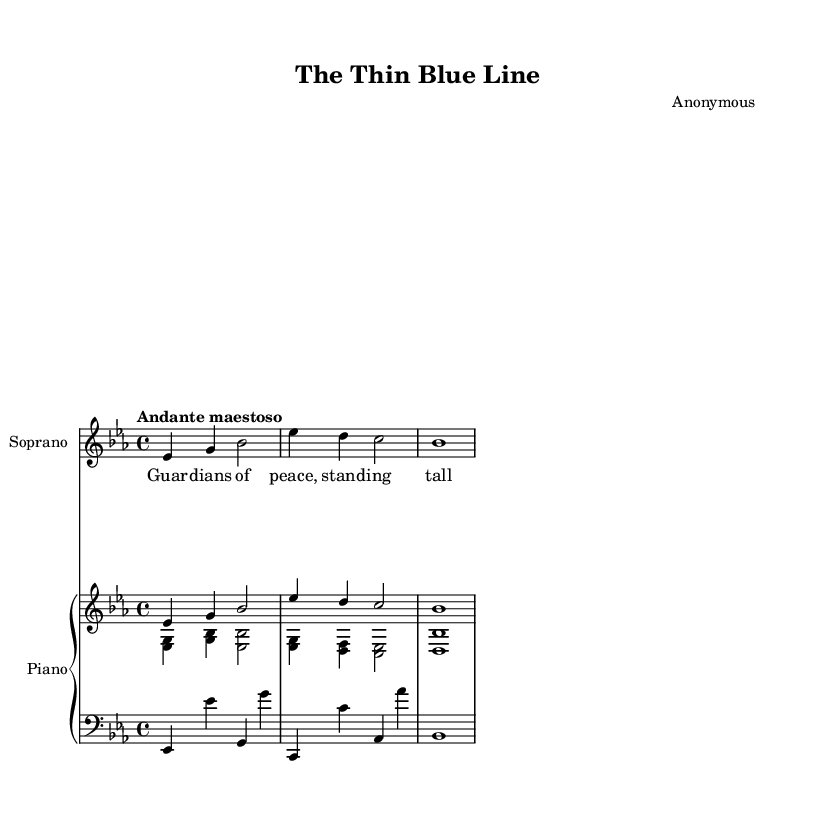What is the key signature of this music? The key signature is determined by the number of sharps or flats at the beginning of the staff. In this sheet music, there are three flats (B, E, and A), which indicates that it is in E-flat major.
Answer: E-flat major What is the time signature of this piece? The time signature is indicated at the beginning of the staff just after the key signature. It shows 4 over 4, meaning four beats per measure and a quarter note gets one beat.
Answer: 4/4 What is the tempo marking given for this piece? The tempo is specified in the sheet music, showing how fast the piece should be played. In this case, the term "Andante maestoso" indicates a moderate tempo that is dignified and majestic in character.
Answer: Andante maestoso Which instrument is specified as the primary performer in the score? The primary instrument is noted at the start of the staff for the vocal line, which is labeled as "Soprano." This indicates that the Soprano voice is the main performer for the melody.
Answer: Soprano What is the harmonic structure presented in the left hand of the piano part? The left hand in the piano part contains a series of chords. It begins with the notes E-flat and G, forming the first chord in E-flat major. The notes progress through various chords corresponding to the music's harmonic progression.
Answer: E-flat major chord How many measures are in the melody line? The melody line is represented in the score with clear bar lines indicating measures. There are three visible measures for the vocal melody, counting each division marked by the vertical lines.
Answer: 3 